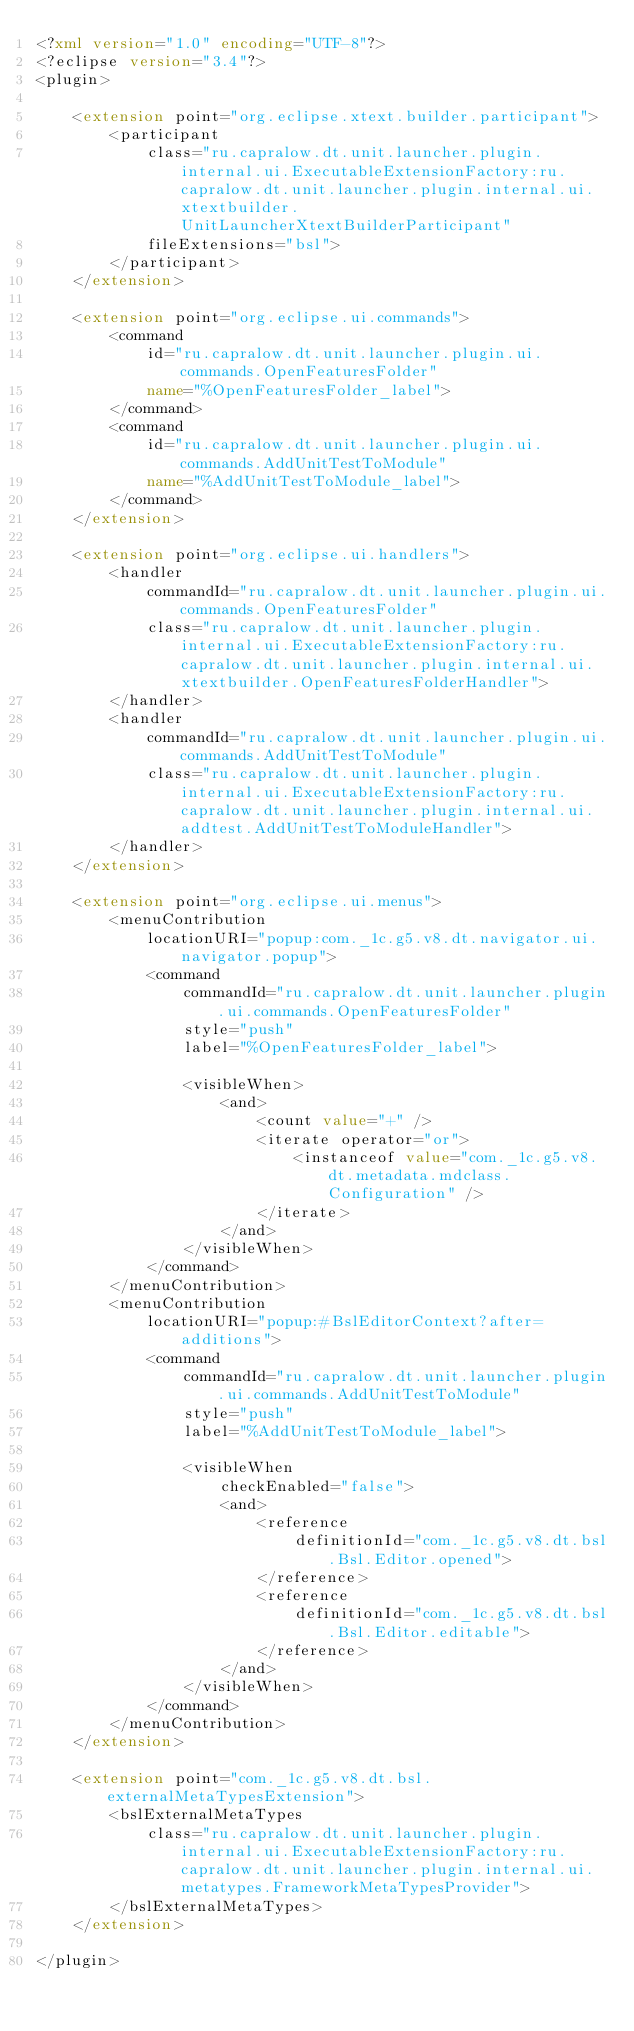Convert code to text. <code><loc_0><loc_0><loc_500><loc_500><_XML_><?xml version="1.0" encoding="UTF-8"?>
<?eclipse version="3.4"?>
<plugin>
	
	<extension point="org.eclipse.xtext.builder.participant">
		<participant
			class="ru.capralow.dt.unit.launcher.plugin.internal.ui.ExecutableExtensionFactory:ru.capralow.dt.unit.launcher.plugin.internal.ui.xtextbuilder.UnitLauncherXtextBuilderParticipant"
			fileExtensions="bsl">
		</participant>
	</extension>
	
	<extension point="org.eclipse.ui.commands">
		<command
			id="ru.capralow.dt.unit.launcher.plugin.ui.commands.OpenFeaturesFolder"
			name="%OpenFeaturesFolder_label">
		</command>
		<command
			id="ru.capralow.dt.unit.launcher.plugin.ui.commands.AddUnitTestToModule"
			name="%AddUnitTestToModule_label">
		</command>
	</extension>
	
	<extension point="org.eclipse.ui.handlers">
		<handler
			commandId="ru.capralow.dt.unit.launcher.plugin.ui.commands.OpenFeaturesFolder"
			class="ru.capralow.dt.unit.launcher.plugin.internal.ui.ExecutableExtensionFactory:ru.capralow.dt.unit.launcher.plugin.internal.ui.xtextbuilder.OpenFeaturesFolderHandler">
		</handler>
		<handler
			commandId="ru.capralow.dt.unit.launcher.plugin.ui.commands.AddUnitTestToModule"
			class="ru.capralow.dt.unit.launcher.plugin.internal.ui.ExecutableExtensionFactory:ru.capralow.dt.unit.launcher.plugin.internal.ui.addtest.AddUnitTestToModuleHandler">
		</handler>
	</extension>
	
	<extension point="org.eclipse.ui.menus">
		<menuContribution
			locationURI="popup:com._1c.g5.v8.dt.navigator.ui.navigator.popup">
			<command
				commandId="ru.capralow.dt.unit.launcher.plugin.ui.commands.OpenFeaturesFolder"
				style="push"
				label="%OpenFeaturesFolder_label">
 
				<visibleWhen>
					<and>
						<count value="+" />
						<iterate operator="or">
							<instanceof value="com._1c.g5.v8.dt.metadata.mdclass.Configuration" />
						</iterate>
					</and>
				</visibleWhen>
			</command>
		</menuContribution>
		<menuContribution
			locationURI="popup:#BslEditorContext?after=additions">
			<command
				commandId="ru.capralow.dt.unit.launcher.plugin.ui.commands.AddUnitTestToModule"
				style="push"
				label="%AddUnitTestToModule_label">
 
				<visibleWhen
					checkEnabled="false">
					<and>
						<reference
							definitionId="com._1c.g5.v8.dt.bsl.Bsl.Editor.opened">
						</reference>
						<reference
							definitionId="com._1c.g5.v8.dt.bsl.Bsl.Editor.editable">
						</reference>
					</and>
				</visibleWhen>
			</command>
		</menuContribution>
	</extension>
	
	<extension point="com._1c.g5.v8.dt.bsl.externalMetaTypesExtension">
		<bslExternalMetaTypes
			class="ru.capralow.dt.unit.launcher.plugin.internal.ui.ExecutableExtensionFactory:ru.capralow.dt.unit.launcher.plugin.internal.ui.metatypes.FrameworkMetaTypesProvider">
		</bslExternalMetaTypes>
	</extension>

</plugin>
</code> 